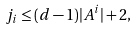Convert formula to latex. <formula><loc_0><loc_0><loc_500><loc_500>j _ { i } \leq ( d - 1 ) | A ^ { i } | + 2 ,</formula> 